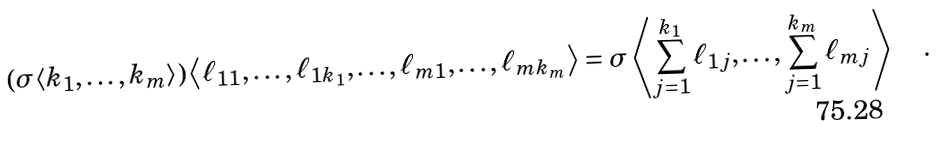Convert formula to latex. <formula><loc_0><loc_0><loc_500><loc_500>\left ( \sigma \langle k _ { 1 } , \dots , k _ { m } \rangle \right ) \left \langle \ell _ { 1 1 } , \dots , \ell _ { 1 k _ { 1 } } , \dots , \ell _ { m 1 } , \dots , \ell _ { m k _ { m } } \right \rangle = \sigma \left \langle \sum _ { j = 1 } ^ { k _ { 1 } } \ell _ { 1 j } , \dots , \sum _ { j = 1 } ^ { k _ { m } } \ell _ { m j } \right \rangle \quad .</formula> 